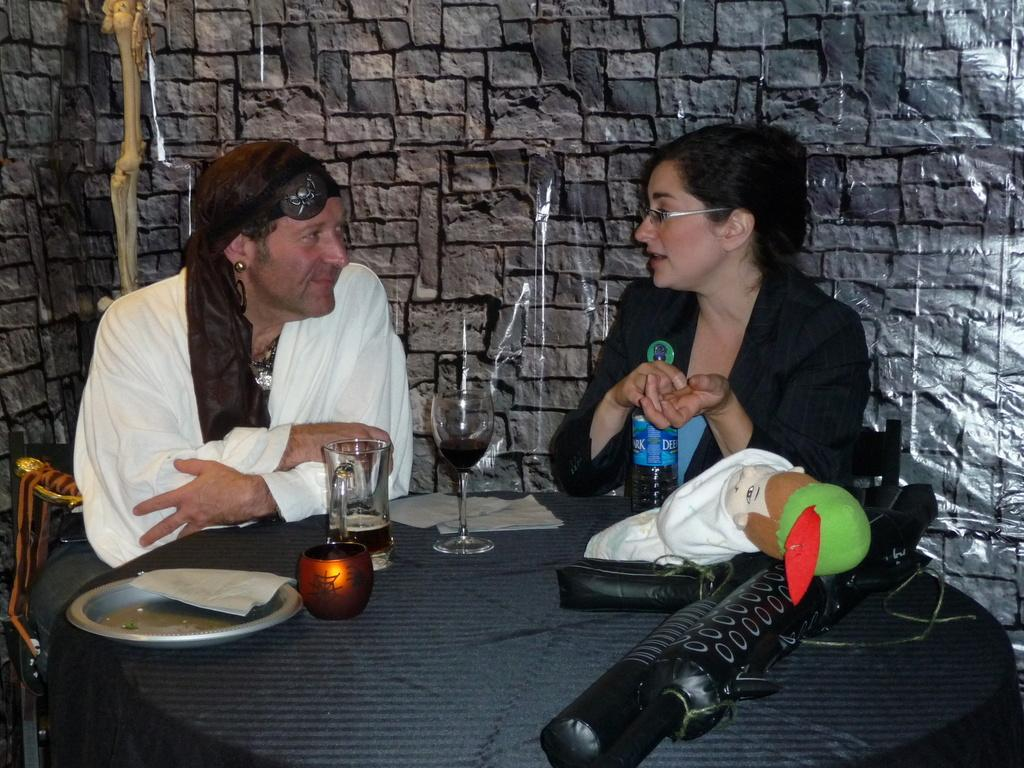How many people are sitting in the chairs in the image? There are two persons sitting on chairs in the image. What is in front of the chairs? There is a table in front of the chairs. What can be seen on the table? There are glasses and other objects on the table. What is the wall made of at the back? The wall at the back is made of bricks. What is the price of the company's latest product in the image? There is no reference to a company or any products in the image, so it is not possible to determine the price of any product. 